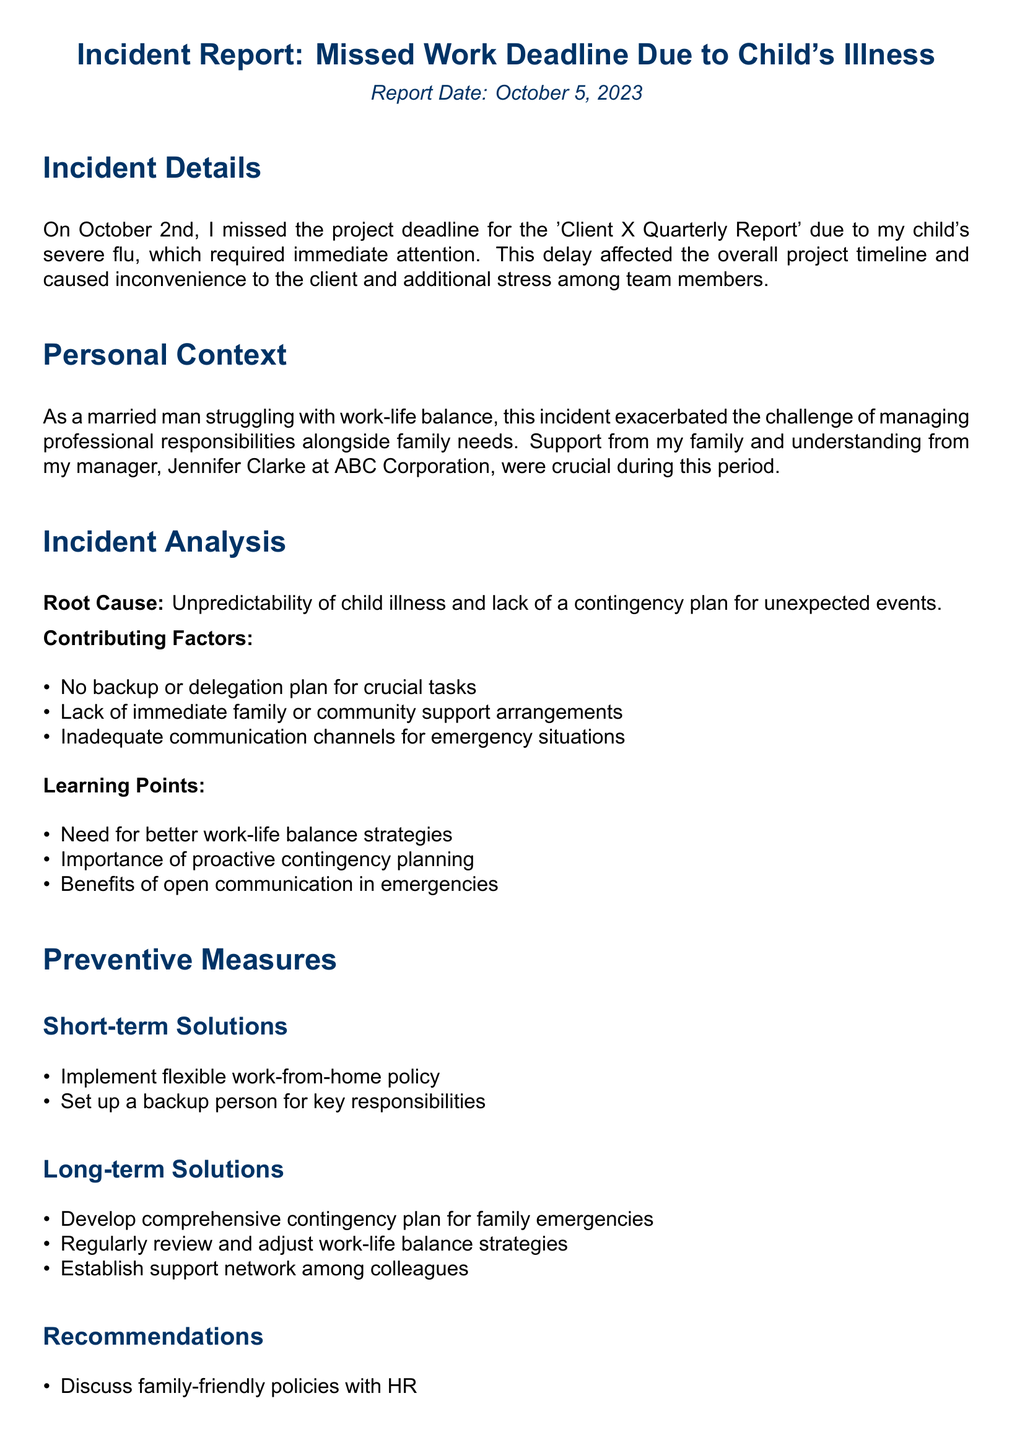What is the report date? The report date is mentioned in the document as October 5, 2023.
Answer: October 5, 2023 What was the project for which the deadline was missed? The document specifies the project as the 'Client X Quarterly Report'.
Answer: Client X Quarterly Report When did the incident occur? The incident is reported to have happened on October 2nd.
Answer: October 2nd Who is the manager mentioned in the report? The report states that the manager is Jennifer Clarke at ABC Corporation.
Answer: Jennifer Clarke What is identified as a root cause of the missed deadline? The document highlights the unpredictability of child illness as the root cause.
Answer: Unpredictability of child illness What is one of the short-term solutions suggested? The document suggests implementing a flexible work-from-home policy as a short-term solution.
Answer: Flexible work-from-home policy What is a learning point from the incident? The report mentions the need for better work-life balance strategies as a learning point.
Answer: Better work-life balance strategies How many contributing factors are listed? There are three contributing factors outlined in the document.
Answer: Three What is a recommendation made in the report? The document recommends discussing family-friendly policies with HR.
Answer: Family-friendly policies with HR What type of report is this document? This document is categorized as an incident report.
Answer: Incident report 